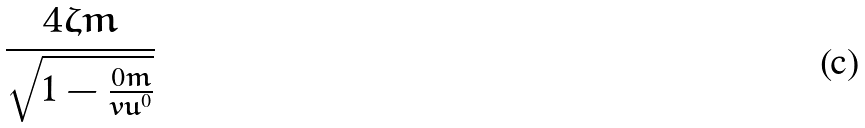<formula> <loc_0><loc_0><loc_500><loc_500>\frac { 4 \zeta m } { \sqrt { 1 - \frac { 0 m } { v u ^ { 0 } } } }</formula> 